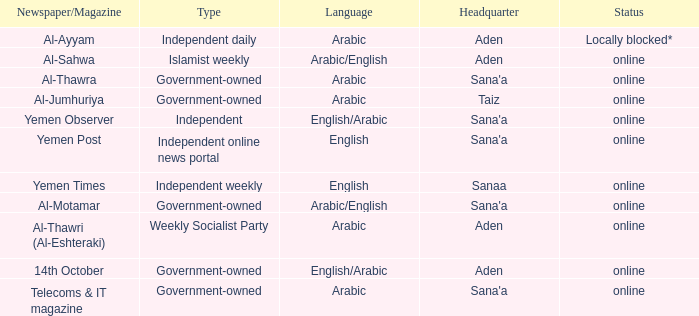What is Type, when Newspaper/Magazine is Telecoms & It Magazine? Government-owned. 